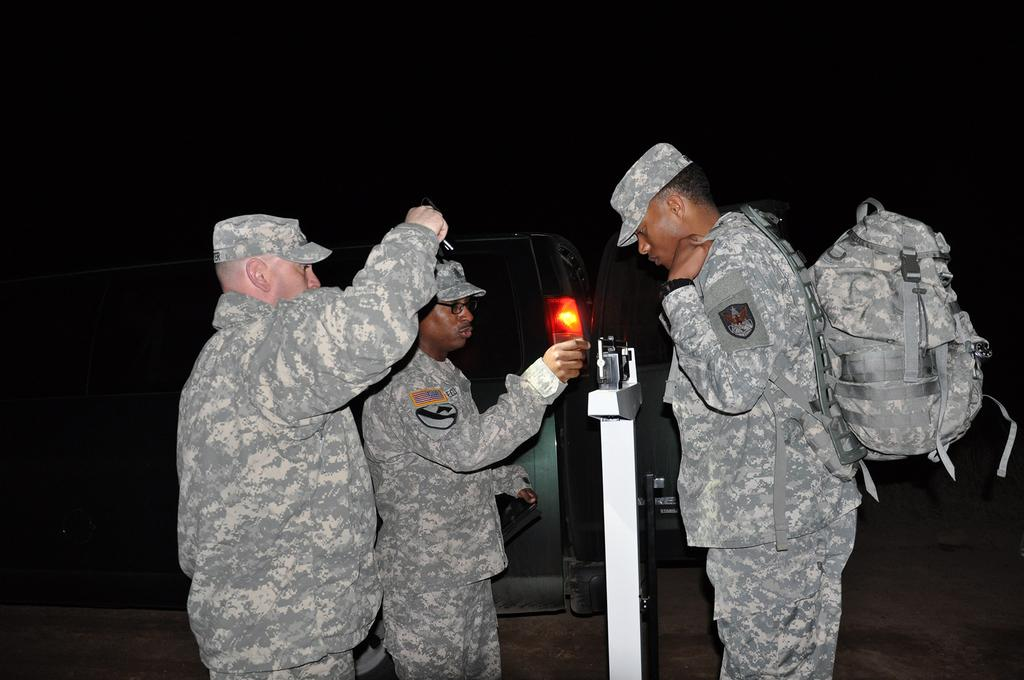How many people are in the image? There are three persons standing in the image. What are the people wearing? The three persons are wearing military dress and caps. Can you describe any accessories they are carrying? One person is carrying a bag. What else can be seen in the distance? There is a vehicle visible in the distance. Can you see a frog hopping near the vehicle in the image? There is no frog visible in the image, nor is there any indication of a frog hopping near the vehicle. 